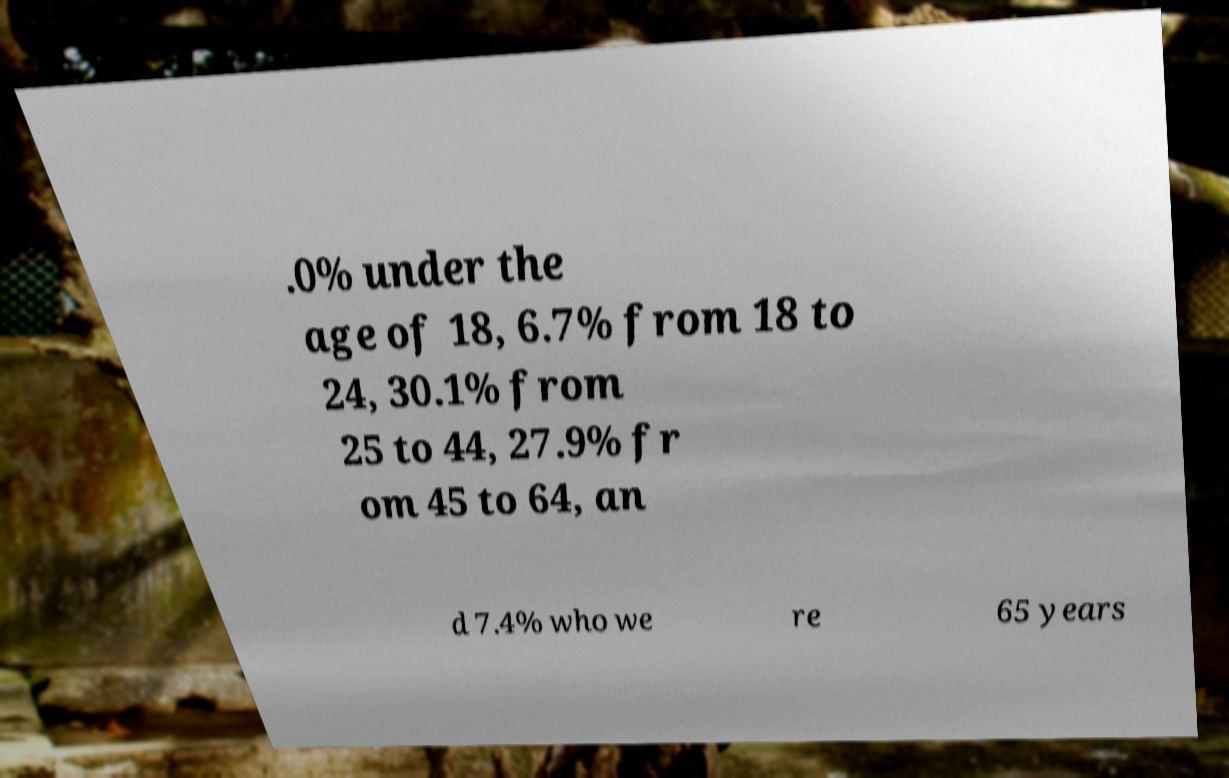Can you accurately transcribe the text from the provided image for me? .0% under the age of 18, 6.7% from 18 to 24, 30.1% from 25 to 44, 27.9% fr om 45 to 64, an d 7.4% who we re 65 years 